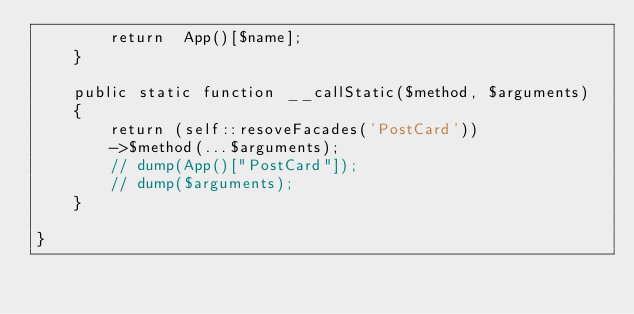<code> <loc_0><loc_0><loc_500><loc_500><_PHP_>        return  App()[$name];
    }
    
    public static function __callStatic($method, $arguments)
    {
        return (self::resoveFacades('PostCard'))
        ->$method(...$arguments);
        // dump(App()["PostCard"]);
        // dump($arguments);
    }

}</code> 